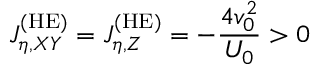Convert formula to latex. <formula><loc_0><loc_0><loc_500><loc_500>J _ { \eta , X Y } ^ { ( H E ) } = J _ { \eta , Z } ^ { ( H E ) } = - \frac { 4 v _ { 0 } ^ { 2 } } { U _ { 0 } } > 0</formula> 